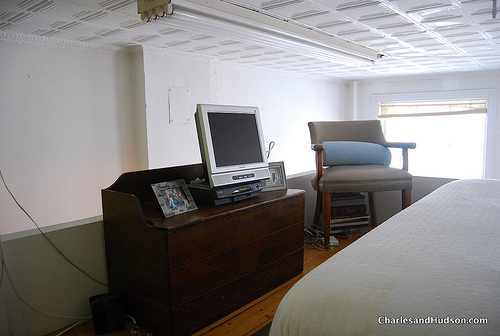How does the chair next to the window look like, red or gray? The chair next to the window has a soothing gray palette, complementing the subtle color scheme of the room. 